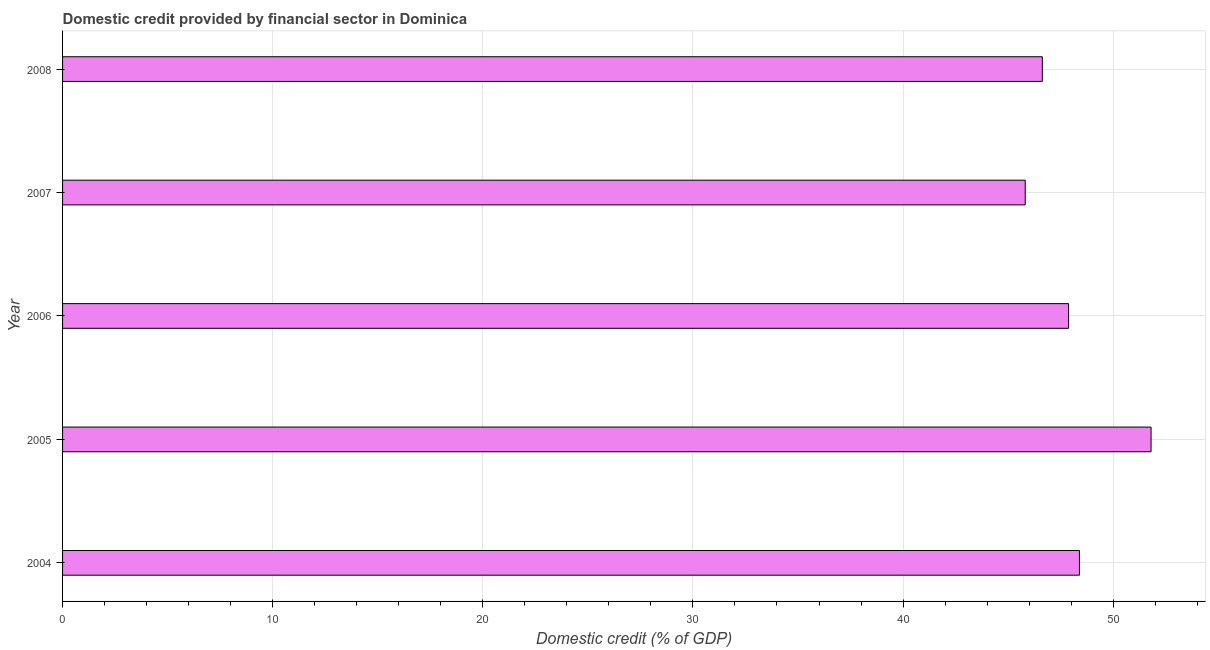Does the graph contain any zero values?
Your answer should be very brief. No. Does the graph contain grids?
Your response must be concise. Yes. What is the title of the graph?
Make the answer very short. Domestic credit provided by financial sector in Dominica. What is the label or title of the X-axis?
Keep it short and to the point. Domestic credit (% of GDP). What is the domestic credit provided by financial sector in 2008?
Keep it short and to the point. 46.63. Across all years, what is the maximum domestic credit provided by financial sector?
Keep it short and to the point. 51.8. Across all years, what is the minimum domestic credit provided by financial sector?
Provide a succinct answer. 45.81. In which year was the domestic credit provided by financial sector minimum?
Your answer should be compact. 2007. What is the sum of the domestic credit provided by financial sector?
Provide a short and direct response. 240.52. What is the difference between the domestic credit provided by financial sector in 2005 and 2007?
Make the answer very short. 5.99. What is the average domestic credit provided by financial sector per year?
Offer a very short reply. 48.1. What is the median domestic credit provided by financial sector?
Give a very brief answer. 47.88. Do a majority of the years between 2006 and 2004 (inclusive) have domestic credit provided by financial sector greater than 22 %?
Your answer should be compact. Yes. What is the ratio of the domestic credit provided by financial sector in 2007 to that in 2008?
Give a very brief answer. 0.98. Is the domestic credit provided by financial sector in 2006 less than that in 2008?
Provide a short and direct response. No. What is the difference between the highest and the second highest domestic credit provided by financial sector?
Offer a very short reply. 3.41. What is the difference between the highest and the lowest domestic credit provided by financial sector?
Your response must be concise. 5.99. How many bars are there?
Make the answer very short. 5. Are all the bars in the graph horizontal?
Your answer should be compact. Yes. How many years are there in the graph?
Your answer should be very brief. 5. What is the Domestic credit (% of GDP) in 2004?
Provide a succinct answer. 48.4. What is the Domestic credit (% of GDP) in 2005?
Ensure brevity in your answer.  51.8. What is the Domestic credit (% of GDP) of 2006?
Make the answer very short. 47.88. What is the Domestic credit (% of GDP) in 2007?
Keep it short and to the point. 45.81. What is the Domestic credit (% of GDP) in 2008?
Make the answer very short. 46.63. What is the difference between the Domestic credit (% of GDP) in 2004 and 2005?
Your answer should be compact. -3.41. What is the difference between the Domestic credit (% of GDP) in 2004 and 2006?
Your answer should be very brief. 0.52. What is the difference between the Domestic credit (% of GDP) in 2004 and 2007?
Offer a terse response. 2.58. What is the difference between the Domestic credit (% of GDP) in 2004 and 2008?
Your answer should be compact. 1.77. What is the difference between the Domestic credit (% of GDP) in 2005 and 2006?
Your answer should be very brief. 3.92. What is the difference between the Domestic credit (% of GDP) in 2005 and 2007?
Your answer should be very brief. 5.99. What is the difference between the Domestic credit (% of GDP) in 2005 and 2008?
Your response must be concise. 5.18. What is the difference between the Domestic credit (% of GDP) in 2006 and 2007?
Your response must be concise. 2.07. What is the difference between the Domestic credit (% of GDP) in 2006 and 2008?
Give a very brief answer. 1.25. What is the difference between the Domestic credit (% of GDP) in 2007 and 2008?
Your answer should be compact. -0.81. What is the ratio of the Domestic credit (% of GDP) in 2004 to that in 2005?
Make the answer very short. 0.93. What is the ratio of the Domestic credit (% of GDP) in 2004 to that in 2006?
Your answer should be compact. 1.01. What is the ratio of the Domestic credit (% of GDP) in 2004 to that in 2007?
Your response must be concise. 1.06. What is the ratio of the Domestic credit (% of GDP) in 2004 to that in 2008?
Provide a short and direct response. 1.04. What is the ratio of the Domestic credit (% of GDP) in 2005 to that in 2006?
Provide a succinct answer. 1.08. What is the ratio of the Domestic credit (% of GDP) in 2005 to that in 2007?
Your answer should be very brief. 1.13. What is the ratio of the Domestic credit (% of GDP) in 2005 to that in 2008?
Keep it short and to the point. 1.11. What is the ratio of the Domestic credit (% of GDP) in 2006 to that in 2007?
Give a very brief answer. 1.04. What is the ratio of the Domestic credit (% of GDP) in 2007 to that in 2008?
Your answer should be compact. 0.98. 